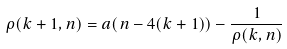Convert formula to latex. <formula><loc_0><loc_0><loc_500><loc_500>\rho ( k + 1 , n ) = a ( n - 4 ( k + 1 ) ) - \frac { 1 } { \rho ( k , n ) }</formula> 